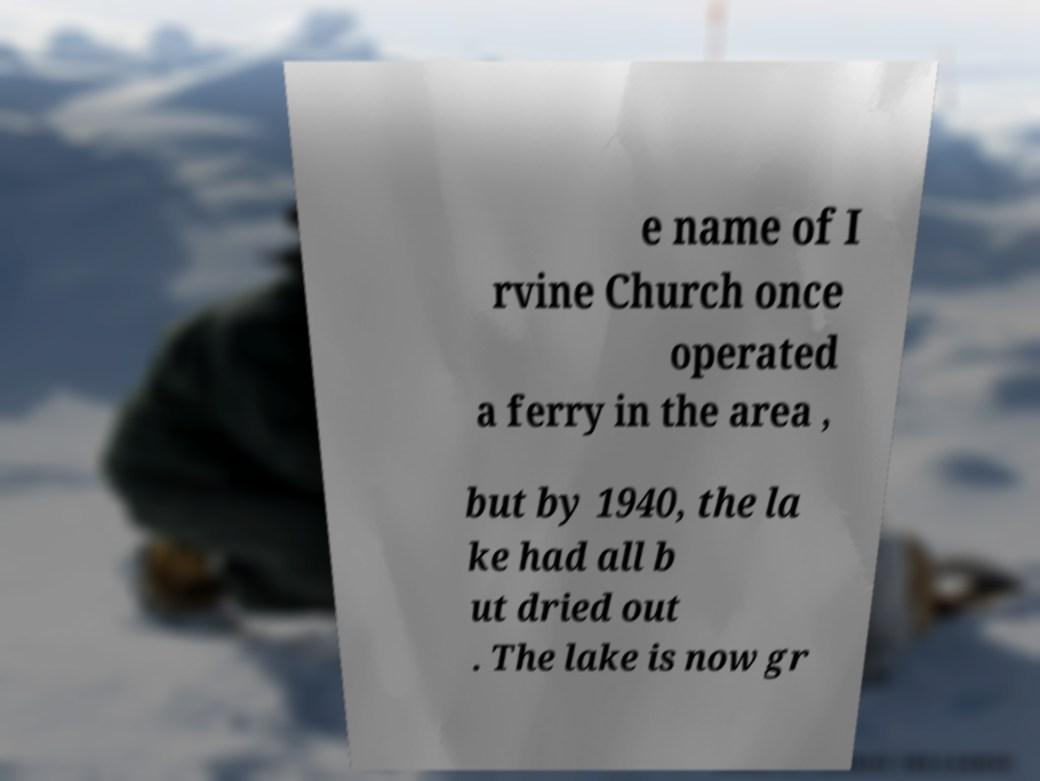For documentation purposes, I need the text within this image transcribed. Could you provide that? e name of I rvine Church once operated a ferry in the area , but by 1940, the la ke had all b ut dried out . The lake is now gr 